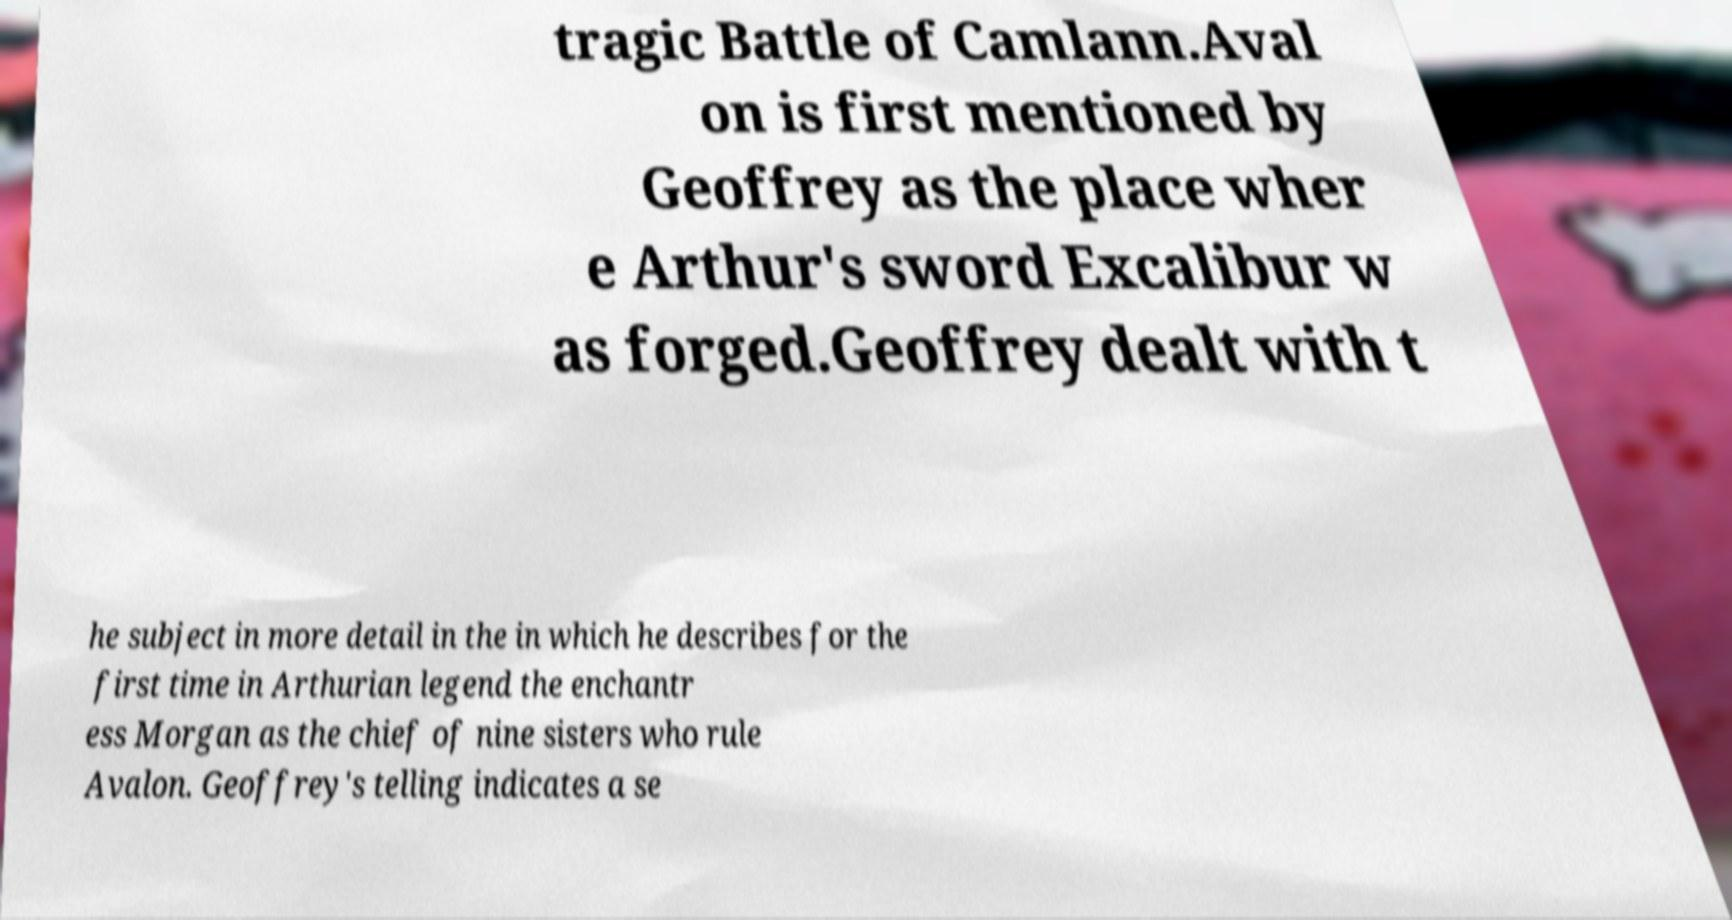For documentation purposes, I need the text within this image transcribed. Could you provide that? tragic Battle of Camlann.Aval on is first mentioned by Geoffrey as the place wher e Arthur's sword Excalibur w as forged.Geoffrey dealt with t he subject in more detail in the in which he describes for the first time in Arthurian legend the enchantr ess Morgan as the chief of nine sisters who rule Avalon. Geoffrey's telling indicates a se 